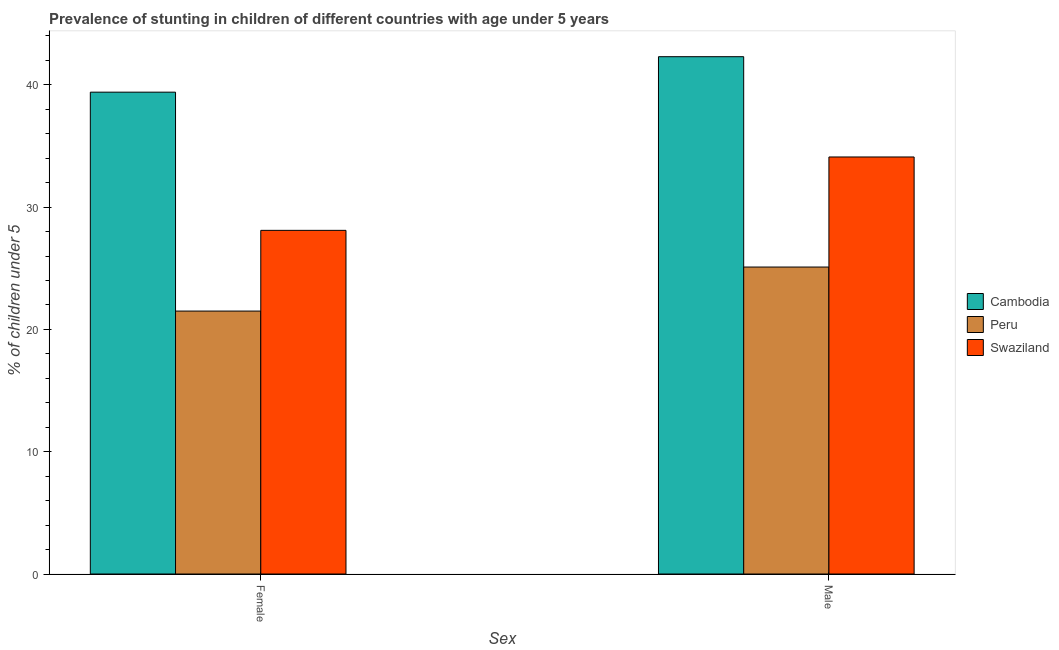Are the number of bars per tick equal to the number of legend labels?
Your answer should be very brief. Yes. Are the number of bars on each tick of the X-axis equal?
Provide a succinct answer. Yes. How many bars are there on the 1st tick from the left?
Offer a terse response. 3. How many bars are there on the 1st tick from the right?
Provide a short and direct response. 3. What is the label of the 2nd group of bars from the left?
Offer a very short reply. Male. What is the percentage of stunted male children in Cambodia?
Your answer should be very brief. 42.3. Across all countries, what is the maximum percentage of stunted female children?
Your answer should be very brief. 39.4. Across all countries, what is the minimum percentage of stunted male children?
Make the answer very short. 25.1. In which country was the percentage of stunted female children maximum?
Keep it short and to the point. Cambodia. What is the total percentage of stunted female children in the graph?
Offer a terse response. 89. What is the difference between the percentage of stunted male children in Peru and that in Cambodia?
Make the answer very short. -17.2. What is the difference between the percentage of stunted male children in Cambodia and the percentage of stunted female children in Swaziland?
Your answer should be compact. 14.2. What is the average percentage of stunted male children per country?
Offer a very short reply. 33.83. What is the difference between the percentage of stunted male children and percentage of stunted female children in Swaziland?
Give a very brief answer. 6. What is the ratio of the percentage of stunted female children in Swaziland to that in Cambodia?
Offer a very short reply. 0.71. Is the percentage of stunted female children in Swaziland less than that in Peru?
Your answer should be compact. No. What does the 1st bar from the left in Female represents?
Your answer should be compact. Cambodia. How many bars are there?
Provide a succinct answer. 6. What is the difference between two consecutive major ticks on the Y-axis?
Keep it short and to the point. 10. Does the graph contain any zero values?
Offer a very short reply. No. What is the title of the graph?
Your answer should be very brief. Prevalence of stunting in children of different countries with age under 5 years. Does "Afghanistan" appear as one of the legend labels in the graph?
Your response must be concise. No. What is the label or title of the X-axis?
Give a very brief answer. Sex. What is the label or title of the Y-axis?
Keep it short and to the point.  % of children under 5. What is the  % of children under 5 of Cambodia in Female?
Your answer should be compact. 39.4. What is the  % of children under 5 in Peru in Female?
Your answer should be compact. 21.5. What is the  % of children under 5 of Swaziland in Female?
Ensure brevity in your answer.  28.1. What is the  % of children under 5 of Cambodia in Male?
Your answer should be compact. 42.3. What is the  % of children under 5 in Peru in Male?
Provide a succinct answer. 25.1. What is the  % of children under 5 of Swaziland in Male?
Your answer should be compact. 34.1. Across all Sex, what is the maximum  % of children under 5 of Cambodia?
Your response must be concise. 42.3. Across all Sex, what is the maximum  % of children under 5 in Peru?
Provide a succinct answer. 25.1. Across all Sex, what is the maximum  % of children under 5 of Swaziland?
Give a very brief answer. 34.1. Across all Sex, what is the minimum  % of children under 5 in Cambodia?
Ensure brevity in your answer.  39.4. Across all Sex, what is the minimum  % of children under 5 of Swaziland?
Your answer should be very brief. 28.1. What is the total  % of children under 5 of Cambodia in the graph?
Ensure brevity in your answer.  81.7. What is the total  % of children under 5 of Peru in the graph?
Ensure brevity in your answer.  46.6. What is the total  % of children under 5 of Swaziland in the graph?
Make the answer very short. 62.2. What is the difference between the  % of children under 5 of Peru in Female and that in Male?
Offer a terse response. -3.6. What is the difference between the  % of children under 5 in Cambodia in Female and the  % of children under 5 in Swaziland in Male?
Make the answer very short. 5.3. What is the average  % of children under 5 in Cambodia per Sex?
Provide a short and direct response. 40.85. What is the average  % of children under 5 of Peru per Sex?
Offer a very short reply. 23.3. What is the average  % of children under 5 in Swaziland per Sex?
Provide a succinct answer. 31.1. What is the difference between the  % of children under 5 of Cambodia and  % of children under 5 of Peru in Female?
Offer a very short reply. 17.9. What is the difference between the  % of children under 5 of Peru and  % of children under 5 of Swaziland in Female?
Offer a terse response. -6.6. What is the difference between the  % of children under 5 in Cambodia and  % of children under 5 in Swaziland in Male?
Ensure brevity in your answer.  8.2. What is the ratio of the  % of children under 5 in Cambodia in Female to that in Male?
Make the answer very short. 0.93. What is the ratio of the  % of children under 5 in Peru in Female to that in Male?
Give a very brief answer. 0.86. What is the ratio of the  % of children under 5 in Swaziland in Female to that in Male?
Give a very brief answer. 0.82. What is the difference between the highest and the lowest  % of children under 5 of Peru?
Your response must be concise. 3.6. What is the difference between the highest and the lowest  % of children under 5 in Swaziland?
Provide a short and direct response. 6. 